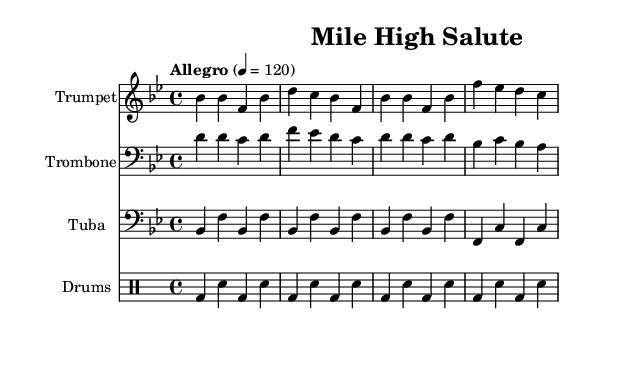What is the key signature of this music? The key signature indicated at the beginning of the sheet music shows two flats, which signifies that it is in the key of B flat major.
Answer: B flat major What is the time signature of this music? The time signature indicated in the sheet music is 4/4, shown at the beginning. This means there are four beats per measure and a quarter note gets one beat.
Answer: 4/4 What is the tempo marking for this piece? The tempo marking in the sheet music states "Allegro" with a metronome marking of 120 beats per minute, indicating a fast tempo.
Answer: Allegro, 120 Which instrument plays the melody? The trumpet is the instrument that plays the prominent melody line, as it is the first staff listed with the melodic notes above the lyrics.
Answer: Trumpet How many measures does the music contain? By counting the number of measure divisions in the sheet music, we can see there are a total of four measures in each instrumental section, making for a concise structure.
Answer: Four measures What is the function of the drum part in this piece? The drum part, indicated as a separate staff using the drum notation, provides supporting rhythm and enhances the overall drive of the music, essential for a fight song's energetic feel.
Answer: Rhythm support What are the lyrics associated with the trumpet part? The lyrics under the trumpet part start with "Mile High Salute! Broncos charging through!" which serves to convey the spirit and pride of the Denver Broncos.
Answer: Mile High Salute! Broncos charging through! 